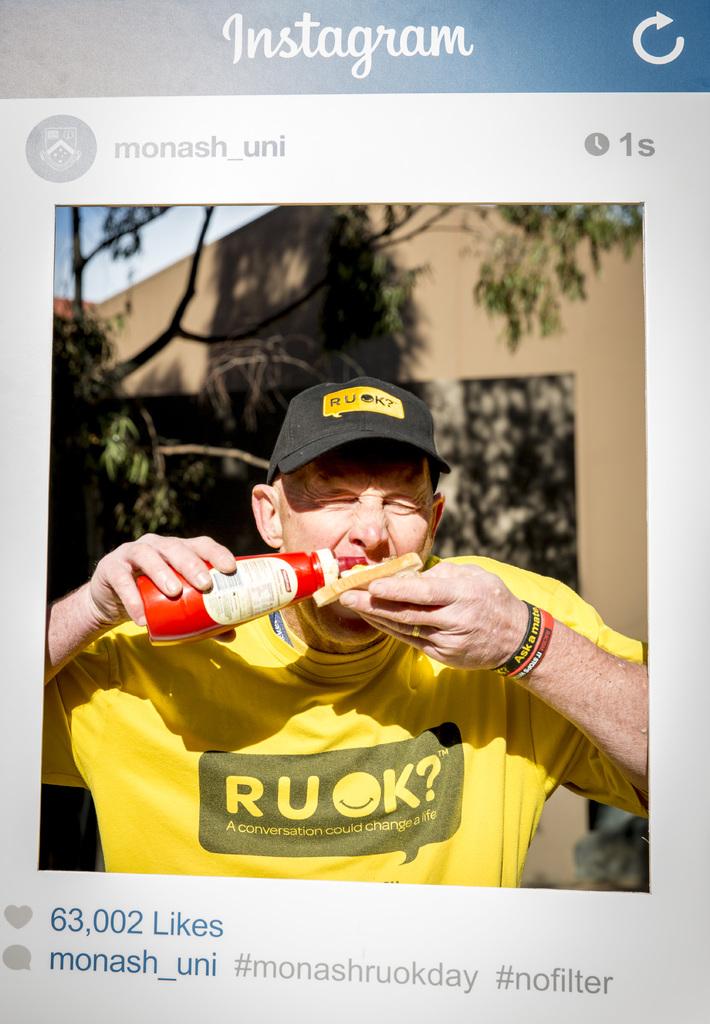What is the app being displayed?
Give a very brief answer. Instagram. What does the shirt say can change a life?
Keep it short and to the point. A conversation. 